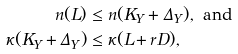Convert formula to latex. <formula><loc_0><loc_0><loc_500><loc_500>n ( L ) & \leq n ( K _ { Y } + \Delta _ { Y } ) , \text { and } \\ \kappa ( K _ { Y } + \Delta _ { Y } ) & \leq \kappa ( L + r D ) ,</formula> 